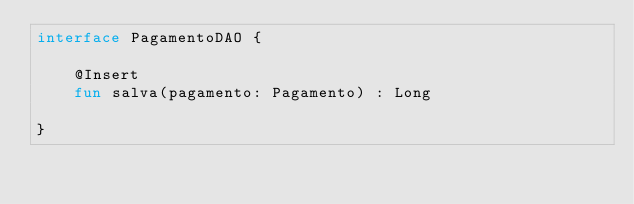<code> <loc_0><loc_0><loc_500><loc_500><_Kotlin_>interface PagamentoDAO {

    @Insert
    fun salva(pagamento: Pagamento) : Long

}</code> 